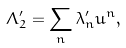Convert formula to latex. <formula><loc_0><loc_0><loc_500><loc_500>\Lambda _ { 2 } ^ { \prime } = \sum _ { n } \lambda _ { n } ^ { \prime } u ^ { n } ,</formula> 